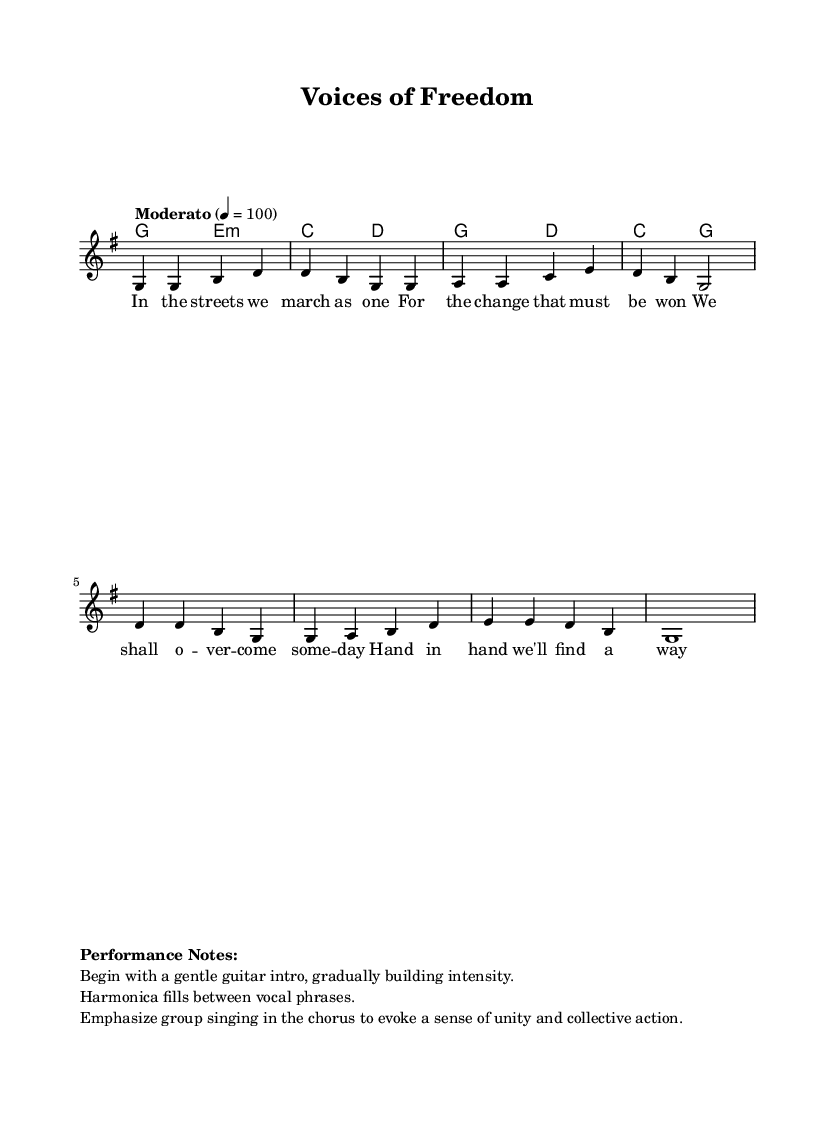What is the key signature of this music? The key signature is identified by the sharp or flat symbols in the music. In this case, there are no accidentals present, indicating it is in G major.
Answer: G major What is the time signature of the music? The time signature is located at the beginning of the sheet music, indicated by a fraction. Here, it is displayed as 4/4, meaning there are four beats per measure.
Answer: 4/4 What is the tempo marking in this piece? The tempo marking indicates how fast the music should be played. It shows “Moderato” with a metronome marking of 4 = 100, suggesting a moderate pace.
Answer: Moderato 4 = 100 How many measures are in the verse? The verse is determined by counting the groupings of notes separated by vertical bar lines. There are four measures in the given verse section.
Answer: Four What type of accompaniment is suggested in the performance notes? The performance notes specify beginning with a gentle guitar intro, implying the use of guitar as the primary accompaniment for this folk piece.
Answer: Guitar Why is group singing emphasized in the chorus? The performance notes indicate a focus on group singing to evoke unity and collective action, which are key themes in folk protest songs.
Answer: Unity What is the overall theme of the lyrics presented in the verse? The lyrics reflect a theme of perseverance and hope for change, consistent with the motifs of social movements in folk music.
Answer: Change 